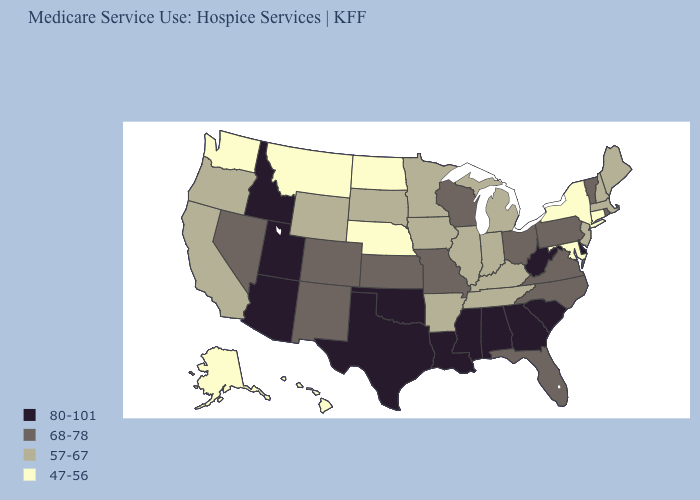Among the states that border Oregon , does Nevada have the highest value?
Be succinct. No. Does Alaska have the lowest value in the West?
Be succinct. Yes. Does the first symbol in the legend represent the smallest category?
Quick response, please. No. Which states have the highest value in the USA?
Concise answer only. Alabama, Arizona, Delaware, Georgia, Idaho, Louisiana, Mississippi, Oklahoma, South Carolina, Texas, Utah, West Virginia. Does Nebraska have the lowest value in the MidWest?
Give a very brief answer. Yes. Name the states that have a value in the range 80-101?
Be succinct. Alabama, Arizona, Delaware, Georgia, Idaho, Louisiana, Mississippi, Oklahoma, South Carolina, Texas, Utah, West Virginia. What is the lowest value in the Northeast?
Concise answer only. 47-56. Among the states that border Washington , does Oregon have the lowest value?
Give a very brief answer. Yes. What is the value of Kansas?
Give a very brief answer. 68-78. Which states have the highest value in the USA?
Keep it brief. Alabama, Arizona, Delaware, Georgia, Idaho, Louisiana, Mississippi, Oklahoma, South Carolina, Texas, Utah, West Virginia. What is the lowest value in the USA?
Short answer required. 47-56. What is the value of Nebraska?
Concise answer only. 47-56. Name the states that have a value in the range 80-101?
Give a very brief answer. Alabama, Arizona, Delaware, Georgia, Idaho, Louisiana, Mississippi, Oklahoma, South Carolina, Texas, Utah, West Virginia. Does the first symbol in the legend represent the smallest category?
Answer briefly. No. Does North Dakota have a lower value than Minnesota?
Keep it brief. Yes. 